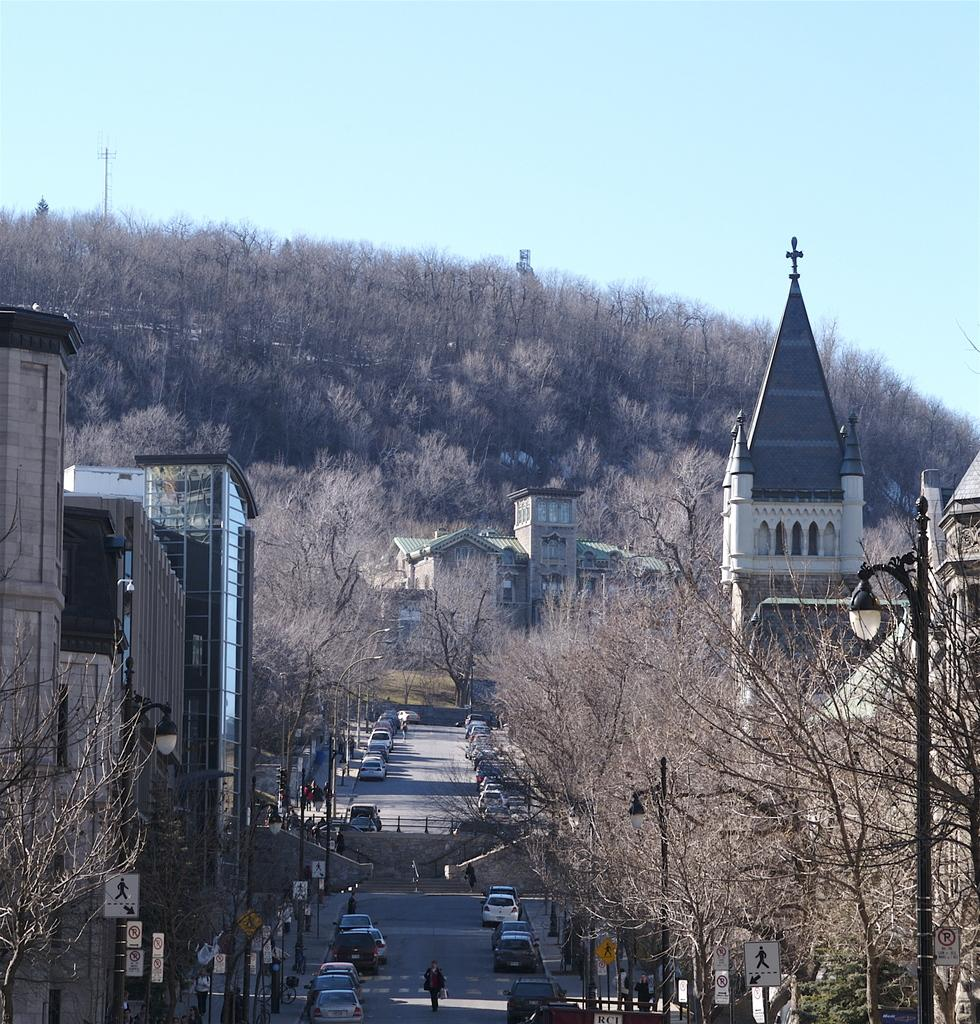What type of structures can be seen in the image? There are buildings in the image. What other natural elements are present in the image? There are trees in the image. What can be seen moving on the road in the image? There are cars and people on the road in the image. What is visible in the background of the image? The sky is visible in the background of the image. What are some man-made objects that provide illumination in the image? There are street lights in the image. What type of signs are present in the image? There are sign boards in the image. What is the wish that the yoke is granting in the image? There is no yoke present in the image, and therefore no wish can be granted by it. What type of destruction is visible in the image? There is no destruction present in the image; it features buildings, trees, cars, people, street lights, and sign boards. 